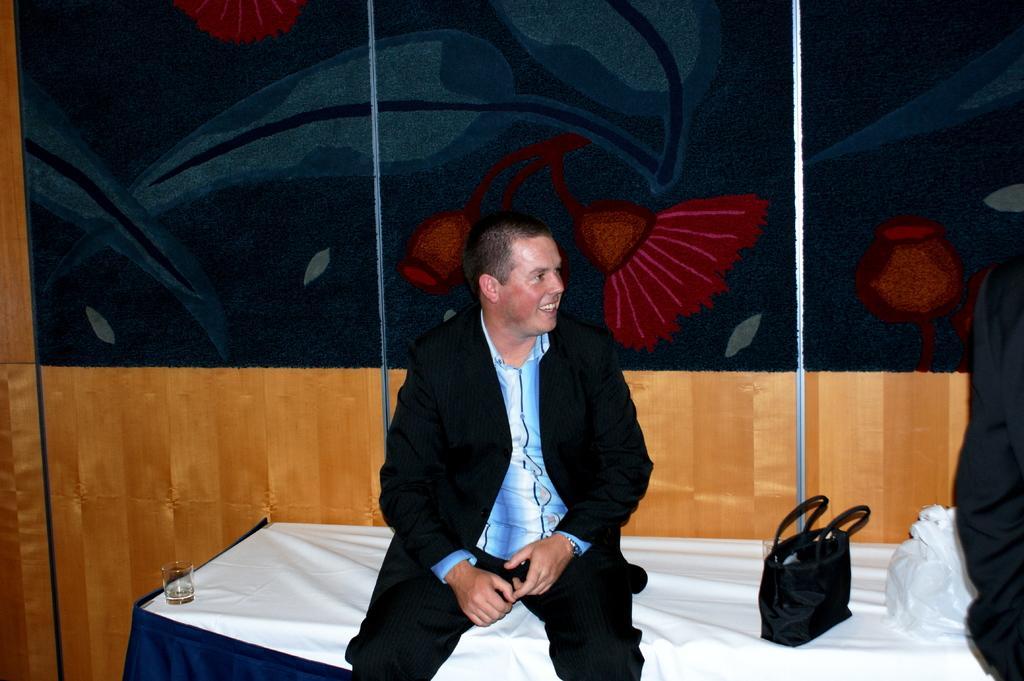Please provide a concise description of this image. The person is sitting on a bed which has a glass of a wine and a black hand bag on it and there is another person standing in the right corner. 